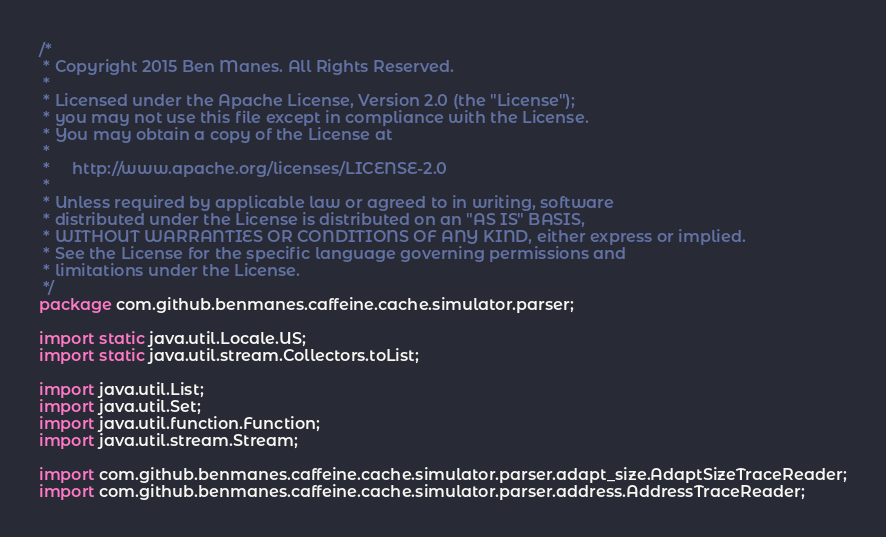Convert code to text. <code><loc_0><loc_0><loc_500><loc_500><_Java_>/*
 * Copyright 2015 Ben Manes. All Rights Reserved.
 *
 * Licensed under the Apache License, Version 2.0 (the "License");
 * you may not use this file except in compliance with the License.
 * You may obtain a copy of the License at
 *
 *     http://www.apache.org/licenses/LICENSE-2.0
 *
 * Unless required by applicable law or agreed to in writing, software
 * distributed under the License is distributed on an "AS IS" BASIS,
 * WITHOUT WARRANTIES OR CONDITIONS OF ANY KIND, either express or implied.
 * See the License for the specific language governing permissions and
 * limitations under the License.
 */
package com.github.benmanes.caffeine.cache.simulator.parser;

import static java.util.Locale.US;
import static java.util.stream.Collectors.toList;

import java.util.List;
import java.util.Set;
import java.util.function.Function;
import java.util.stream.Stream;

import com.github.benmanes.caffeine.cache.simulator.parser.adapt_size.AdaptSizeTraceReader;
import com.github.benmanes.caffeine.cache.simulator.parser.address.AddressTraceReader;</code> 